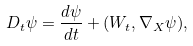<formula> <loc_0><loc_0><loc_500><loc_500>D _ { t } \psi = \frac { d \psi } { d t } + ( W _ { t } , \nabla _ { X } \psi ) ,</formula> 